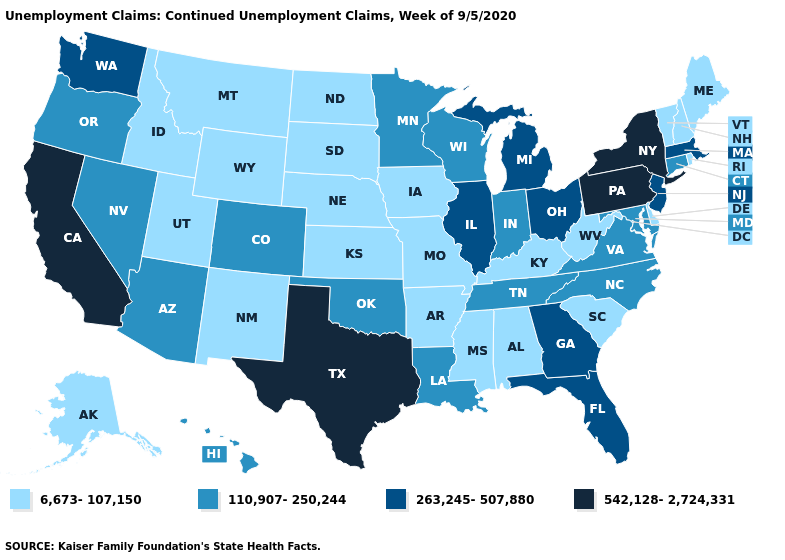Name the states that have a value in the range 542,128-2,724,331?
Write a very short answer. California, New York, Pennsylvania, Texas. What is the value of Massachusetts?
Quick response, please. 263,245-507,880. What is the highest value in the MidWest ?
Write a very short answer. 263,245-507,880. What is the value of Nebraska?
Short answer required. 6,673-107,150. Name the states that have a value in the range 6,673-107,150?
Short answer required. Alabama, Alaska, Arkansas, Delaware, Idaho, Iowa, Kansas, Kentucky, Maine, Mississippi, Missouri, Montana, Nebraska, New Hampshire, New Mexico, North Dakota, Rhode Island, South Carolina, South Dakota, Utah, Vermont, West Virginia, Wyoming. Which states have the lowest value in the South?
Give a very brief answer. Alabama, Arkansas, Delaware, Kentucky, Mississippi, South Carolina, West Virginia. Which states have the highest value in the USA?
Write a very short answer. California, New York, Pennsylvania, Texas. Name the states that have a value in the range 6,673-107,150?
Give a very brief answer. Alabama, Alaska, Arkansas, Delaware, Idaho, Iowa, Kansas, Kentucky, Maine, Mississippi, Missouri, Montana, Nebraska, New Hampshire, New Mexico, North Dakota, Rhode Island, South Carolina, South Dakota, Utah, Vermont, West Virginia, Wyoming. Does New York have the highest value in the USA?
Keep it brief. Yes. What is the highest value in states that border Virginia?
Give a very brief answer. 110,907-250,244. What is the lowest value in states that border Virginia?
Keep it brief. 6,673-107,150. Name the states that have a value in the range 542,128-2,724,331?
Short answer required. California, New York, Pennsylvania, Texas. Does Maine have the lowest value in the Northeast?
Write a very short answer. Yes. Name the states that have a value in the range 542,128-2,724,331?
Quick response, please. California, New York, Pennsylvania, Texas. Does California have a lower value than Colorado?
Answer briefly. No. 